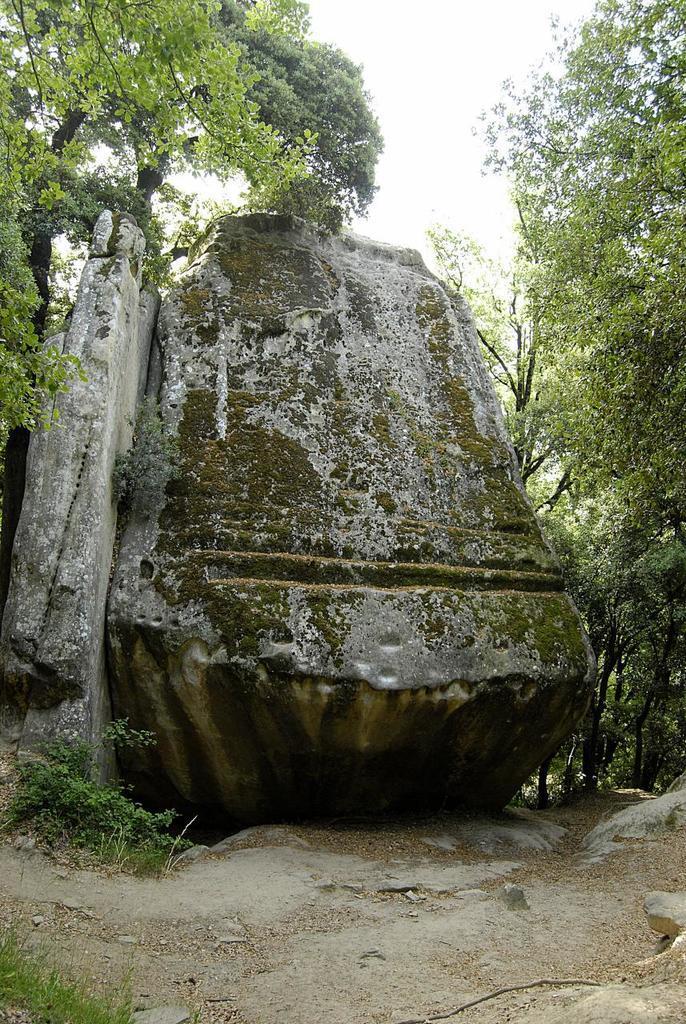Describe this image in one or two sentences. In this image we can see few rocks. There are many trees in the image. There is a sky in the image. There are few plants in the image. 